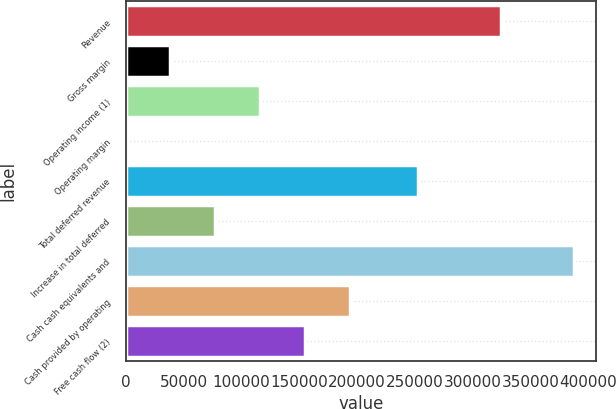Convert chart to OTSL. <chart><loc_0><loc_0><loc_500><loc_500><bar_chart><fcel>Revenue<fcel>Gross margin<fcel>Operating income (1)<fcel>Operating margin<fcel>Total deferred revenue<fcel>Increase in total deferred<fcel>Cash cash equivalents and<fcel>Cash provided by operating<fcel>Free cash flow (2)<nl><fcel>324696<fcel>38761.3<fcel>116250<fcel>17<fcel>252631<fcel>77505.6<fcel>387460<fcel>193738<fcel>154994<nl></chart> 